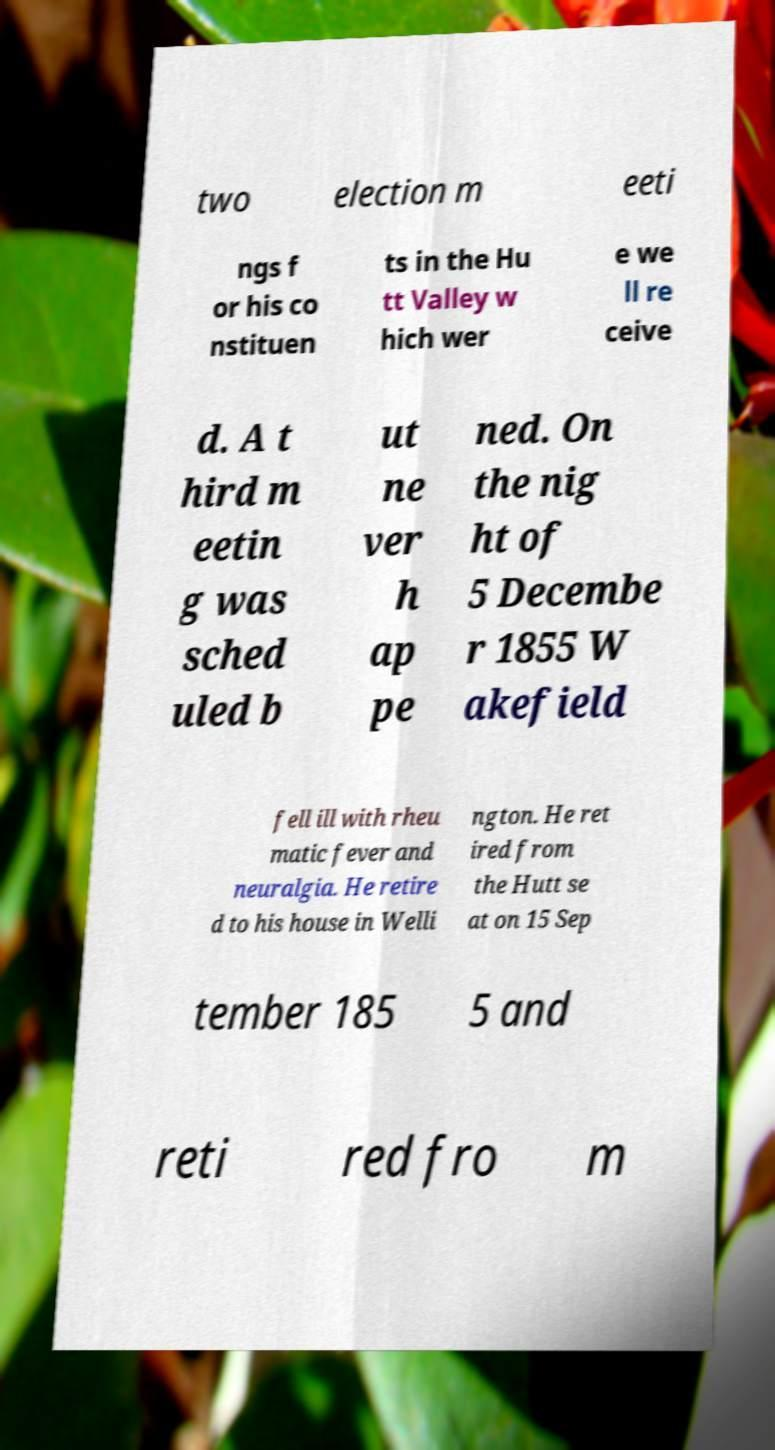There's text embedded in this image that I need extracted. Can you transcribe it verbatim? two election m eeti ngs f or his co nstituen ts in the Hu tt Valley w hich wer e we ll re ceive d. A t hird m eetin g was sched uled b ut ne ver h ap pe ned. On the nig ht of 5 Decembe r 1855 W akefield fell ill with rheu matic fever and neuralgia. He retire d to his house in Welli ngton. He ret ired from the Hutt se at on 15 Sep tember 185 5 and reti red fro m 